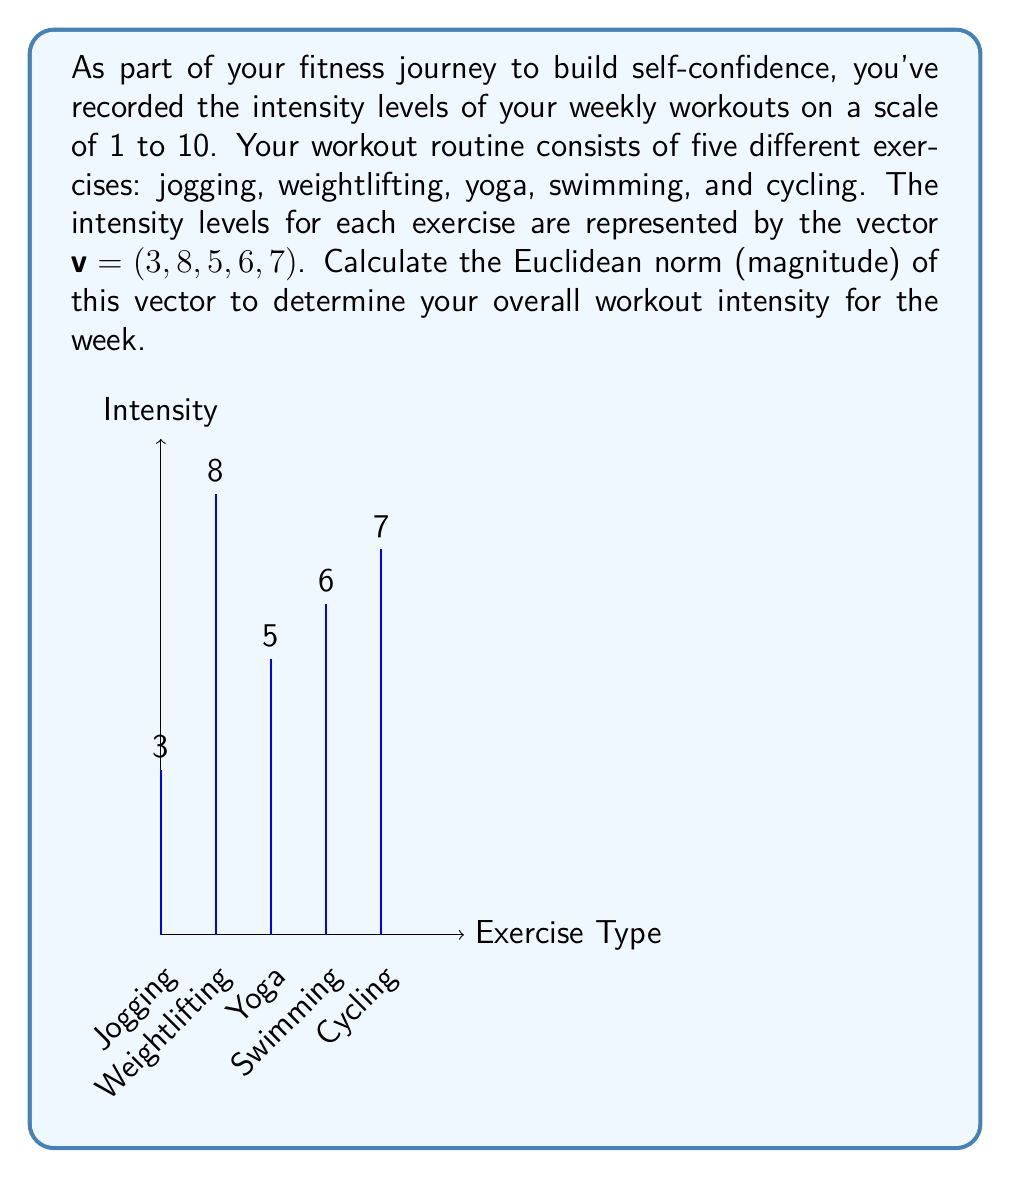Give your solution to this math problem. To calculate the Euclidean norm of the vector $v = (3, 8, 5, 6, 7)$, we follow these steps:

1) The Euclidean norm (also known as L2 norm) of a vector $v = (v_1, v_2, ..., v_n)$ is defined as:

   $$\|v\|_2 = \sqrt{\sum_{i=1}^n |v_i|^2}$$

2) In our case, we have:
   $$\|v\|_2 = \sqrt{|3|^2 + |8|^2 + |5|^2 + |6|^2 + |7|^2}$$

3) Simplify by removing the absolute value signs (as all components are positive):
   $$\|v\|_2 = \sqrt{3^2 + 8^2 + 5^2 + 6^2 + 7^2}$$

4) Calculate the squares:
   $$\|v\|_2 = \sqrt{9 + 64 + 25 + 36 + 49}$$

5) Sum the values under the square root:
   $$\|v\|_2 = \sqrt{183}$$

6) Calculate the square root:
   $$\|v\|_2 \approx 13.53$$

The Euclidean norm of the vector is approximately 13.53, representing your overall workout intensity for the week.
Answer: $\|v\|_2 = \sqrt{183} \approx 13.53$ 